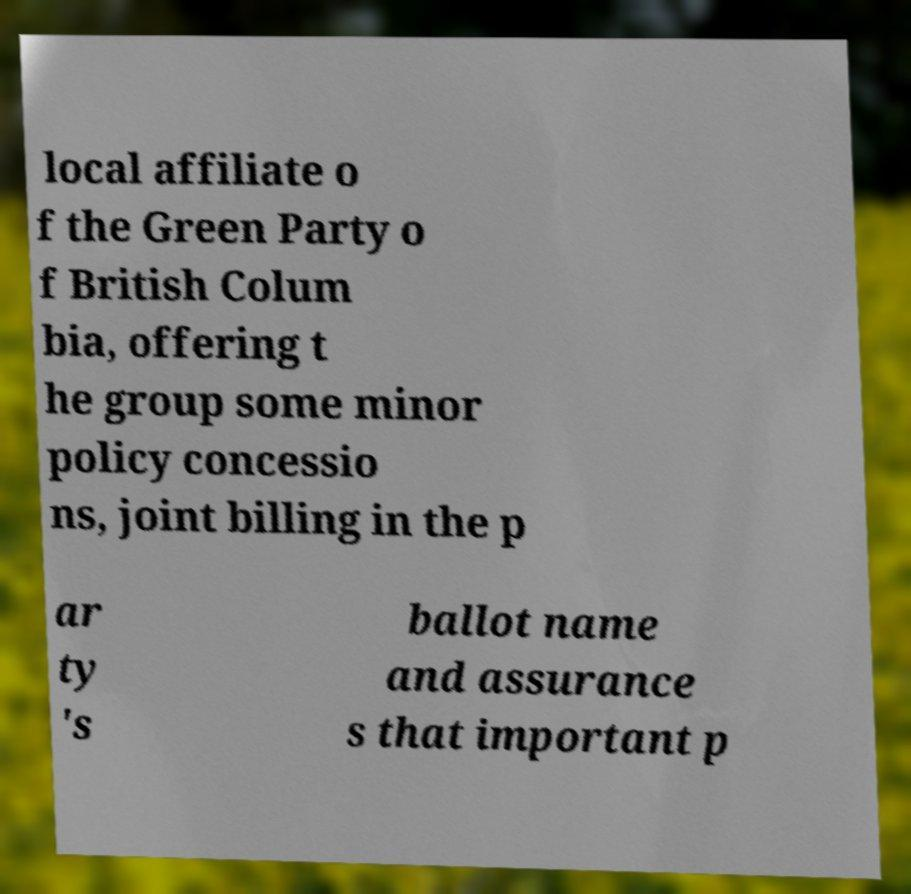Can you accurately transcribe the text from the provided image for me? local affiliate o f the Green Party o f British Colum bia, offering t he group some minor policy concessio ns, joint billing in the p ar ty 's ballot name and assurance s that important p 